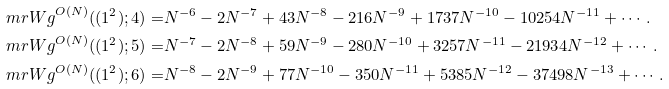<formula> <loc_0><loc_0><loc_500><loc_500>\ m r { W g } ^ { O ( N ) } ( ( 1 ^ { 2 } ) ; 4 ) = & N ^ { - 6 } - 2 N ^ { - 7 } + 4 3 N ^ { - 8 } - 2 1 6 N ^ { - 9 } + 1 7 3 7 N ^ { - 1 0 } - 1 0 2 5 4 N ^ { - 1 1 } + \cdots . \\ \ m r { W g } ^ { O ( N ) } ( ( 1 ^ { 2 } ) ; 5 ) = & N ^ { - 7 } - 2 N ^ { - 8 } + 5 9 N ^ { - 9 } - 2 8 0 N ^ { - 1 0 } + 3 2 5 7 N ^ { - 1 1 } - 2 1 9 3 4 N ^ { - 1 2 } + \cdots . \\ \ m r { W g } ^ { O ( N ) } ( ( 1 ^ { 2 } ) ; 6 ) = & N ^ { - 8 } - 2 N ^ { - 9 } + 7 7 N ^ { - 1 0 } - 3 5 0 N ^ { - 1 1 } + 5 3 8 5 N ^ { - 1 2 } - 3 7 4 9 8 N ^ { - 1 3 } + \cdots .</formula> 